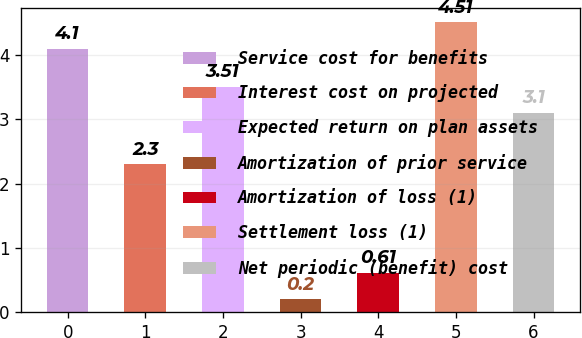<chart> <loc_0><loc_0><loc_500><loc_500><bar_chart><fcel>Service cost for benefits<fcel>Interest cost on projected<fcel>Expected return on plan assets<fcel>Amortization of prior service<fcel>Amortization of loss (1)<fcel>Settlement loss (1)<fcel>Net periodic (benefit) cost<nl><fcel>4.1<fcel>2.3<fcel>3.51<fcel>0.2<fcel>0.61<fcel>4.51<fcel>3.1<nl></chart> 